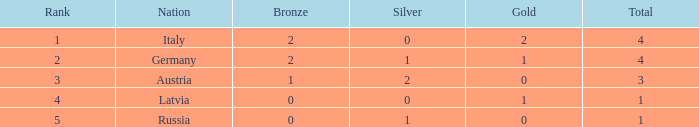What is the average number of silver medals for countries with 0 gold and rank under 3? None. 